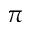<formula> <loc_0><loc_0><loc_500><loc_500>\pi</formula> 